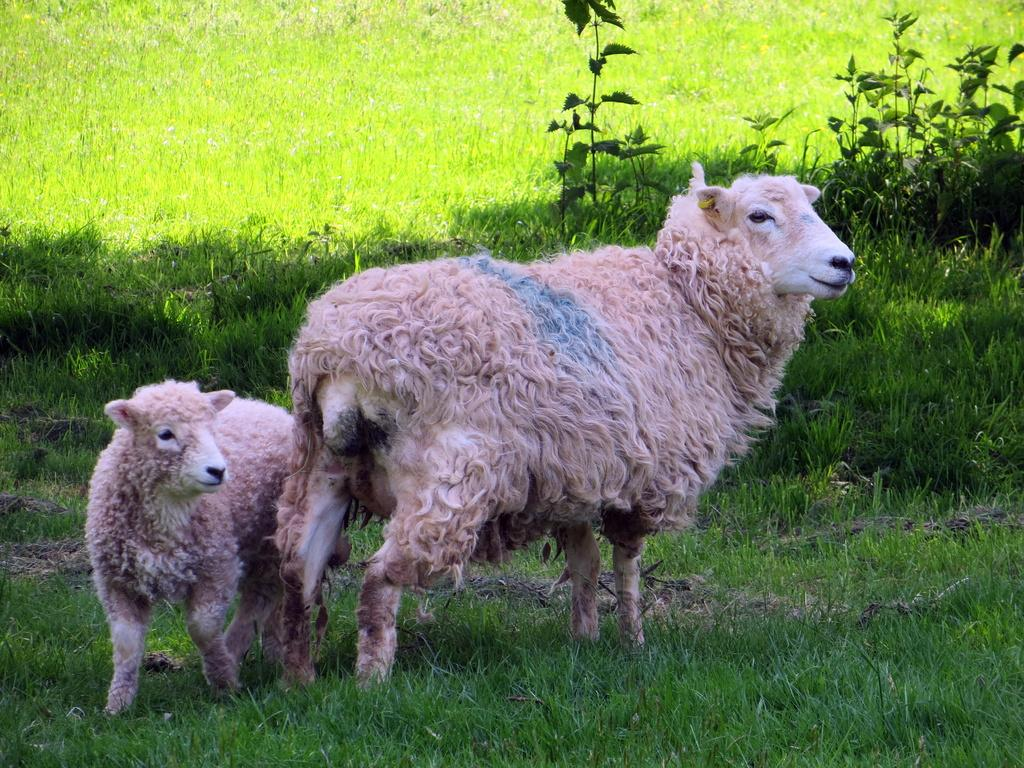How many animals are present in the image? There are two sheep in the image. What are the sheep standing on? The sheep are standing on the grass. What type of vegetation is visible in the background of the image? There is grass and plants visible in the background of the image. What type of nut is the sheep holding in the image? There is no nut present in the image; the sheep are standing on the grass. 